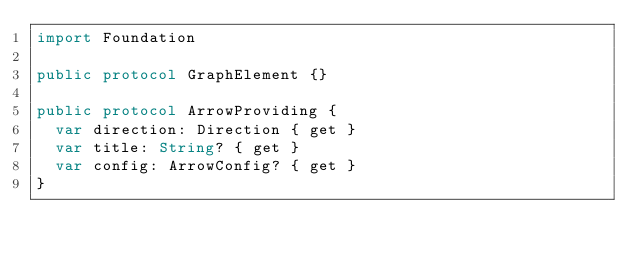<code> <loc_0><loc_0><loc_500><loc_500><_Swift_>import Foundation

public protocol GraphElement {}

public protocol ArrowProviding {
  var direction: Direction { get }
  var title: String? { get }
  var config: ArrowConfig? { get }
}
</code> 